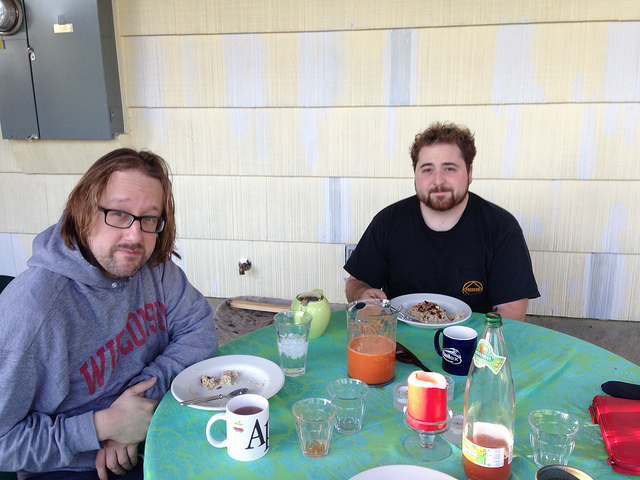Please extract the text content from this image. WI A 